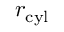<formula> <loc_0><loc_0><loc_500><loc_500>r _ { c y l }</formula> 